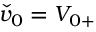<formula> <loc_0><loc_0><loc_500><loc_500>\check { v } _ { 0 } = { V } _ { 0 + }</formula> 